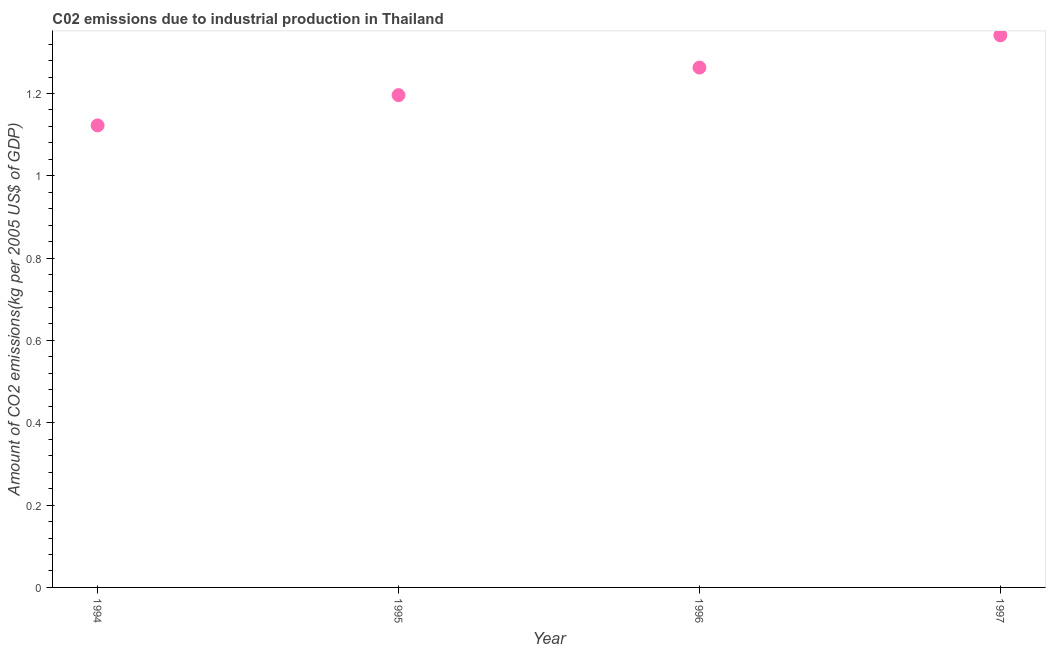What is the amount of co2 emissions in 1996?
Your response must be concise. 1.26. Across all years, what is the maximum amount of co2 emissions?
Make the answer very short. 1.34. Across all years, what is the minimum amount of co2 emissions?
Make the answer very short. 1.12. In which year was the amount of co2 emissions maximum?
Provide a short and direct response. 1997. In which year was the amount of co2 emissions minimum?
Make the answer very short. 1994. What is the sum of the amount of co2 emissions?
Your response must be concise. 4.92. What is the difference between the amount of co2 emissions in 1996 and 1997?
Provide a short and direct response. -0.08. What is the average amount of co2 emissions per year?
Your answer should be very brief. 1.23. What is the median amount of co2 emissions?
Your answer should be compact. 1.23. Do a majority of the years between 1997 and 1994 (inclusive) have amount of co2 emissions greater than 1.04 kg per 2005 US$ of GDP?
Provide a succinct answer. Yes. What is the ratio of the amount of co2 emissions in 1995 to that in 1996?
Your response must be concise. 0.95. Is the amount of co2 emissions in 1994 less than that in 1997?
Your answer should be very brief. Yes. What is the difference between the highest and the second highest amount of co2 emissions?
Your response must be concise. 0.08. Is the sum of the amount of co2 emissions in 1994 and 1996 greater than the maximum amount of co2 emissions across all years?
Your answer should be very brief. Yes. What is the difference between the highest and the lowest amount of co2 emissions?
Your answer should be compact. 0.22. Does the amount of co2 emissions monotonically increase over the years?
Your answer should be compact. Yes. How many dotlines are there?
Offer a very short reply. 1. How many years are there in the graph?
Offer a terse response. 4. Does the graph contain grids?
Your answer should be very brief. No. What is the title of the graph?
Keep it short and to the point. C02 emissions due to industrial production in Thailand. What is the label or title of the X-axis?
Your answer should be very brief. Year. What is the label or title of the Y-axis?
Offer a very short reply. Amount of CO2 emissions(kg per 2005 US$ of GDP). What is the Amount of CO2 emissions(kg per 2005 US$ of GDP) in 1994?
Give a very brief answer. 1.12. What is the Amount of CO2 emissions(kg per 2005 US$ of GDP) in 1995?
Give a very brief answer. 1.2. What is the Amount of CO2 emissions(kg per 2005 US$ of GDP) in 1996?
Your answer should be compact. 1.26. What is the Amount of CO2 emissions(kg per 2005 US$ of GDP) in 1997?
Make the answer very short. 1.34. What is the difference between the Amount of CO2 emissions(kg per 2005 US$ of GDP) in 1994 and 1995?
Make the answer very short. -0.07. What is the difference between the Amount of CO2 emissions(kg per 2005 US$ of GDP) in 1994 and 1996?
Ensure brevity in your answer.  -0.14. What is the difference between the Amount of CO2 emissions(kg per 2005 US$ of GDP) in 1994 and 1997?
Give a very brief answer. -0.22. What is the difference between the Amount of CO2 emissions(kg per 2005 US$ of GDP) in 1995 and 1996?
Your answer should be compact. -0.07. What is the difference between the Amount of CO2 emissions(kg per 2005 US$ of GDP) in 1995 and 1997?
Provide a short and direct response. -0.15. What is the difference between the Amount of CO2 emissions(kg per 2005 US$ of GDP) in 1996 and 1997?
Give a very brief answer. -0.08. What is the ratio of the Amount of CO2 emissions(kg per 2005 US$ of GDP) in 1994 to that in 1995?
Keep it short and to the point. 0.94. What is the ratio of the Amount of CO2 emissions(kg per 2005 US$ of GDP) in 1994 to that in 1996?
Offer a terse response. 0.89. What is the ratio of the Amount of CO2 emissions(kg per 2005 US$ of GDP) in 1994 to that in 1997?
Provide a short and direct response. 0.84. What is the ratio of the Amount of CO2 emissions(kg per 2005 US$ of GDP) in 1995 to that in 1996?
Your answer should be very brief. 0.95. What is the ratio of the Amount of CO2 emissions(kg per 2005 US$ of GDP) in 1995 to that in 1997?
Give a very brief answer. 0.89. What is the ratio of the Amount of CO2 emissions(kg per 2005 US$ of GDP) in 1996 to that in 1997?
Give a very brief answer. 0.94. 